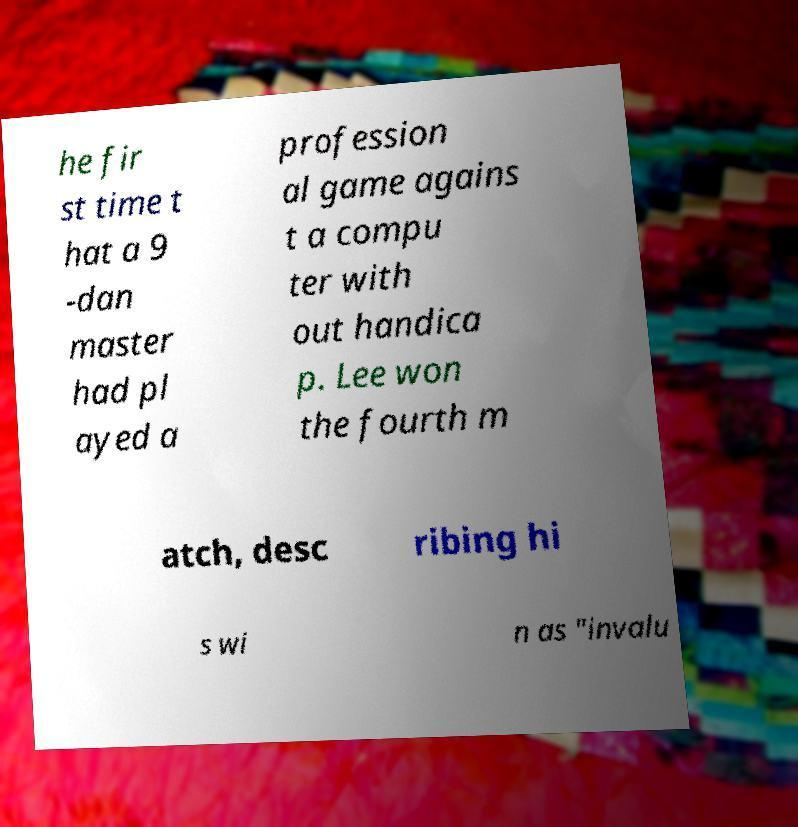What messages or text are displayed in this image? I need them in a readable, typed format. he fir st time t hat a 9 -dan master had pl ayed a profession al game agains t a compu ter with out handica p. Lee won the fourth m atch, desc ribing hi s wi n as "invalu 